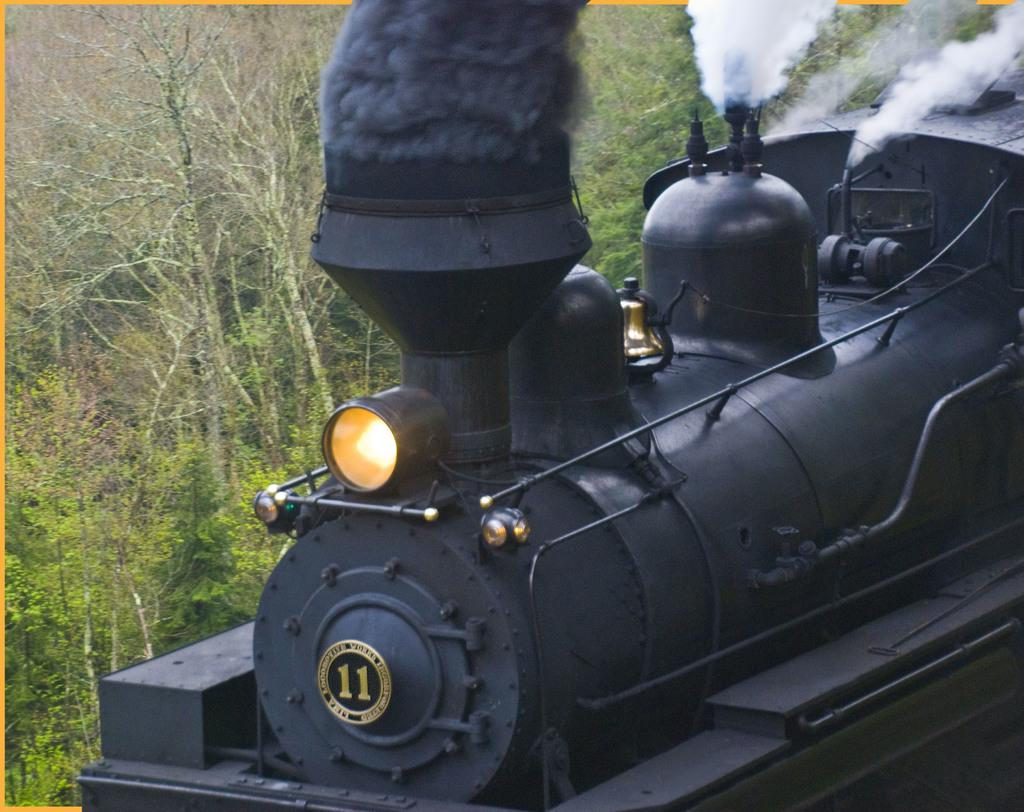<image>
Give a short and clear explanation of the subsequent image. The black steam train has a number 11 on the front of it 